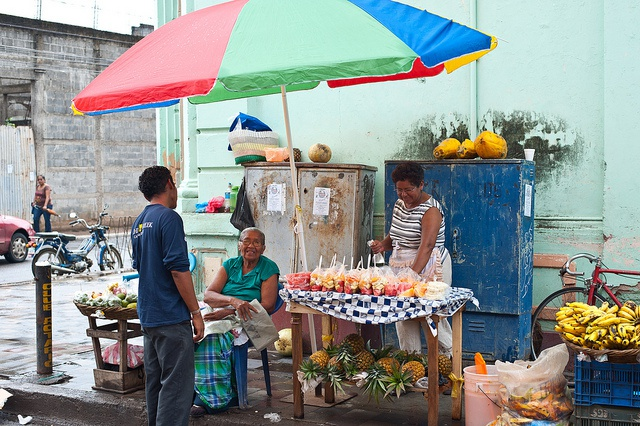Describe the objects in this image and their specific colors. I can see umbrella in white, aquamarine, lightpink, and lightblue tones, people in white, black, navy, darkblue, and maroon tones, people in white, teal, black, maroon, and brown tones, people in white, darkgray, brown, gray, and black tones, and bicycle in white, gray, darkgray, maroon, and black tones in this image. 